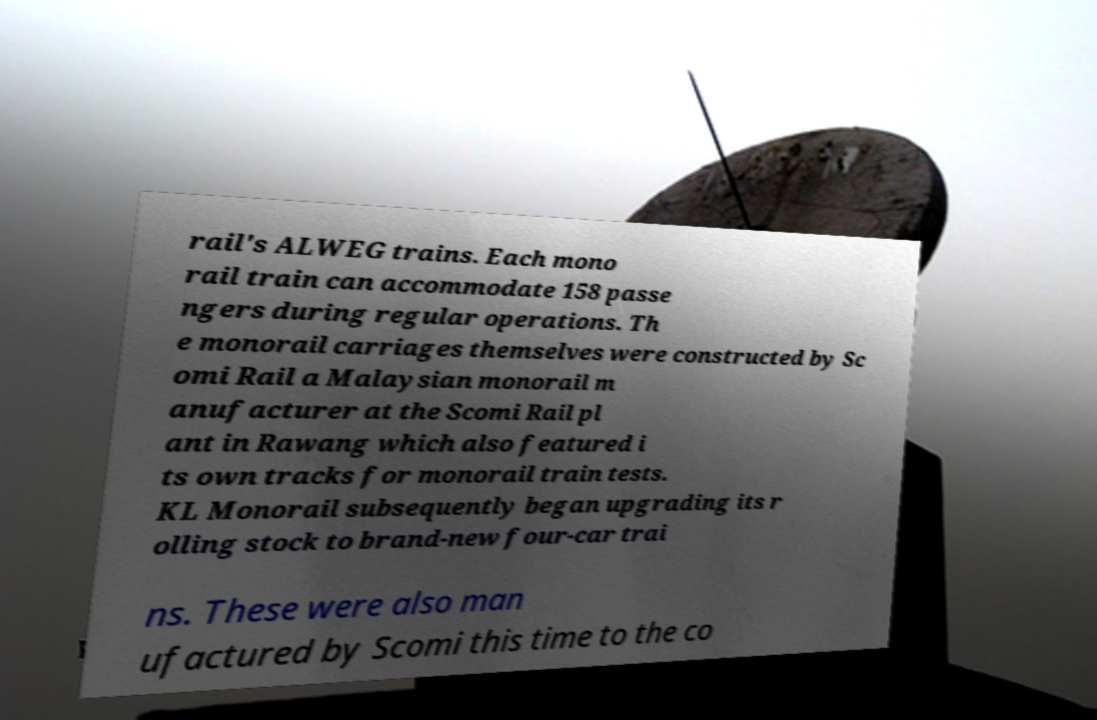Could you extract and type out the text from this image? rail's ALWEG trains. Each mono rail train can accommodate 158 passe ngers during regular operations. Th e monorail carriages themselves were constructed by Sc omi Rail a Malaysian monorail m anufacturer at the Scomi Rail pl ant in Rawang which also featured i ts own tracks for monorail train tests. KL Monorail subsequently began upgrading its r olling stock to brand-new four-car trai ns. These were also man ufactured by Scomi this time to the co 